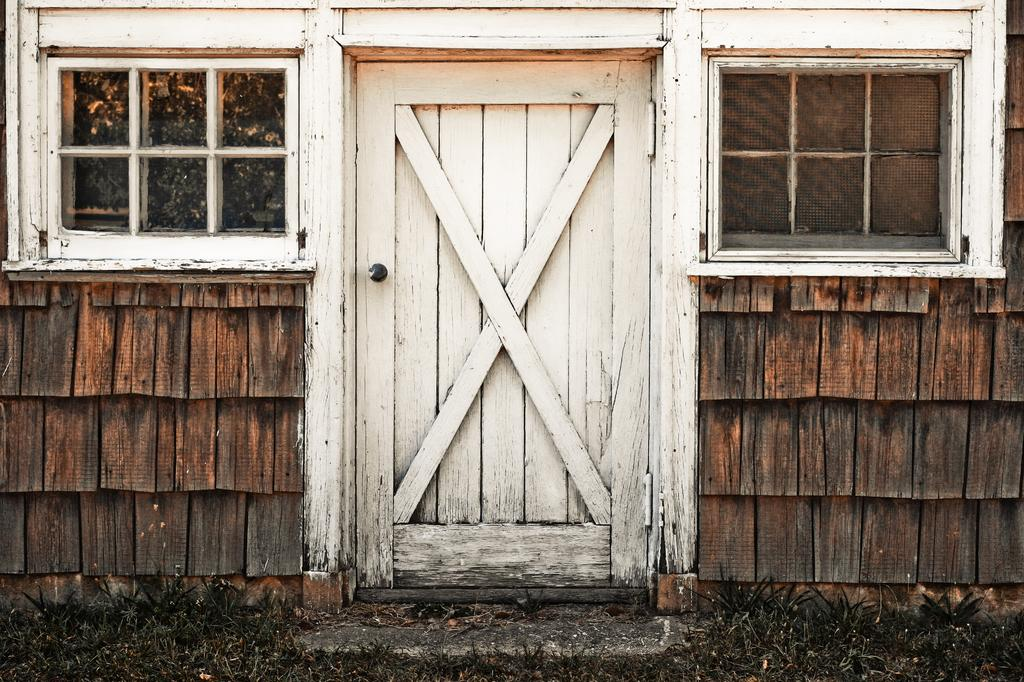What type of structure can be seen in the image? There is a wall in the image. What material is used for the windows in the image? There are glass windows in the image. Is there an entrance visible in the image? Yes, there is a door in the image. Where are the scissors located in the image? There are no scissors present in the image. How many men can be seen in the image? There are no men present in the image. 